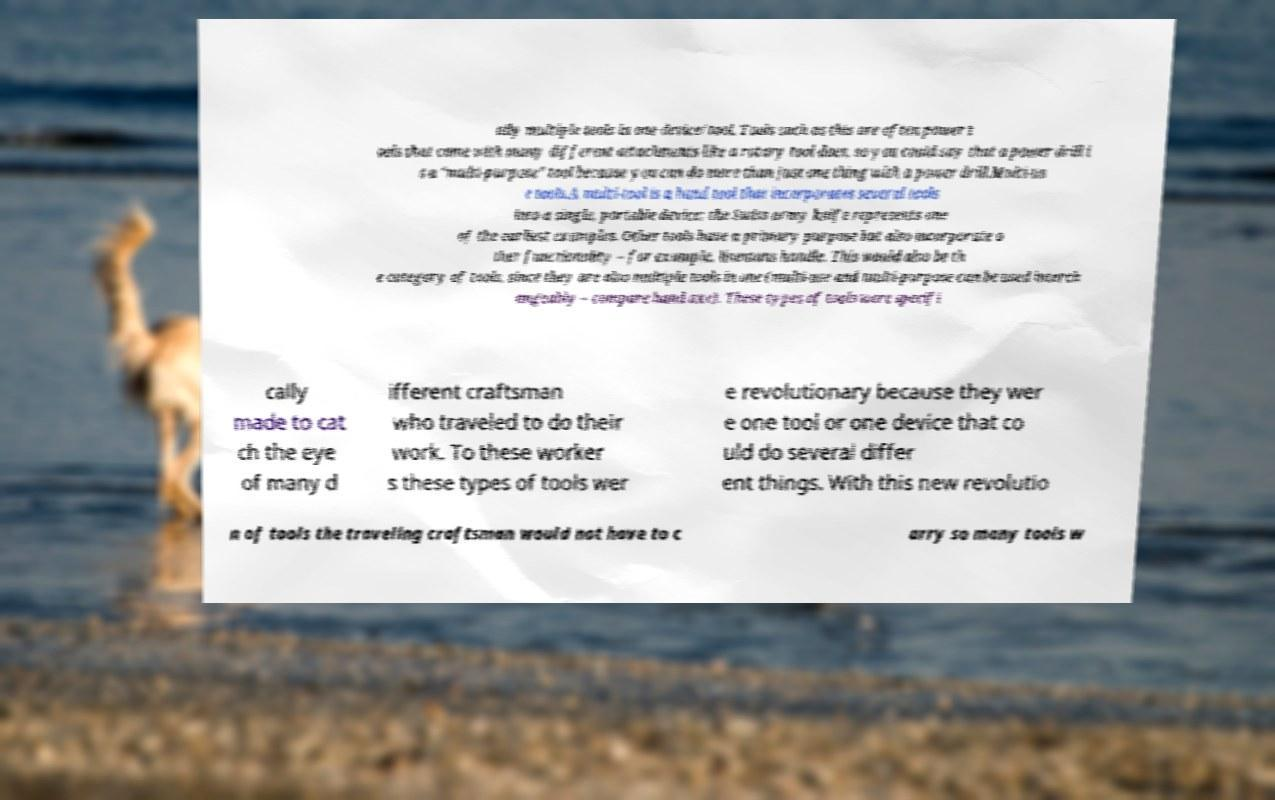I need the written content from this picture converted into text. Can you do that? ally multiple tools in one device/tool. Tools such as this are often power t ools that come with many different attachments like a rotary tool does, so you could say that a power drill i s a "multi-purpose" tool because you can do more than just one thing with a power drill.Multi-us e tools.A multi-tool is a hand tool that incorporates several tools into a single, portable device; the Swiss army knife represents one of the earliest examples. Other tools have a primary purpose but also incorporate o ther functionality – for example, linemans handle. This would also be th e category of tools, since they are also multiple tools in one (multi-use and multi-purpose can be used interch angeably – compare hand axe). These types of tools were specifi cally made to cat ch the eye of many d ifferent craftsman who traveled to do their work. To these worker s these types of tools wer e revolutionary because they wer e one tool or one device that co uld do several differ ent things. With this new revolutio n of tools the traveling craftsman would not have to c arry so many tools w 